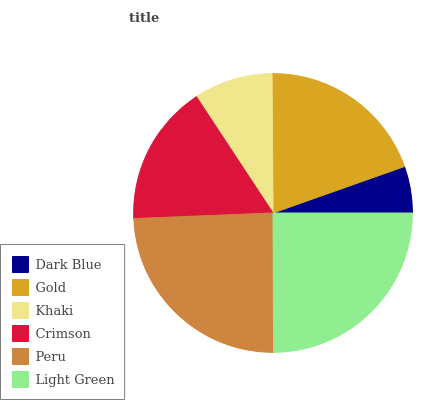Is Dark Blue the minimum?
Answer yes or no. Yes. Is Light Green the maximum?
Answer yes or no. Yes. Is Gold the minimum?
Answer yes or no. No. Is Gold the maximum?
Answer yes or no. No. Is Gold greater than Dark Blue?
Answer yes or no. Yes. Is Dark Blue less than Gold?
Answer yes or no. Yes. Is Dark Blue greater than Gold?
Answer yes or no. No. Is Gold less than Dark Blue?
Answer yes or no. No. Is Gold the high median?
Answer yes or no. Yes. Is Crimson the low median?
Answer yes or no. Yes. Is Crimson the high median?
Answer yes or no. No. Is Light Green the low median?
Answer yes or no. No. 